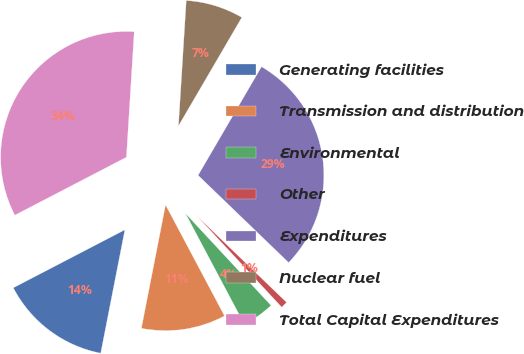Convert chart to OTSL. <chart><loc_0><loc_0><loc_500><loc_500><pie_chart><fcel>Generating facilities<fcel>Transmission and distribution<fcel>Environmental<fcel>Other<fcel>Expenditures<fcel>Nuclear fuel<fcel>Total Capital Expenditures<nl><fcel>14.29%<fcel>10.85%<fcel>4.15%<fcel>0.87%<fcel>28.8%<fcel>7.42%<fcel>33.62%<nl></chart> 